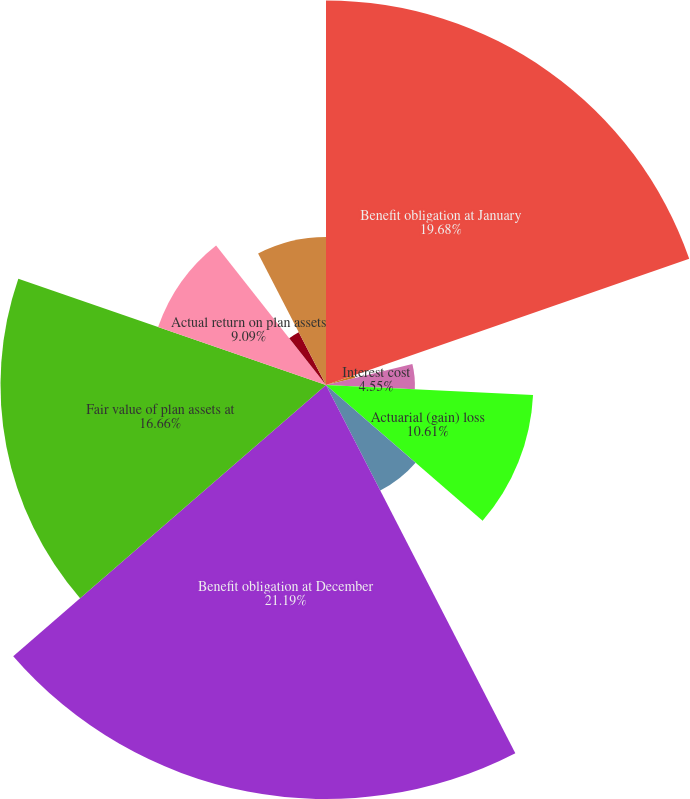<chart> <loc_0><loc_0><loc_500><loc_500><pie_chart><fcel>Benefit obligation at January<fcel>Service cost<fcel>Interest cost<fcel>Actuarial (gain) loss<fcel>Gross benefits paid<fcel>Benefit obligation at December<fcel>Fair value of plan assets at<fcel>Actual return on plan assets<fcel>Employer contributions<fcel>Benefits paid<nl><fcel>19.68%<fcel>1.53%<fcel>4.55%<fcel>10.61%<fcel>6.07%<fcel>21.19%<fcel>16.66%<fcel>9.09%<fcel>3.04%<fcel>7.58%<nl></chart> 